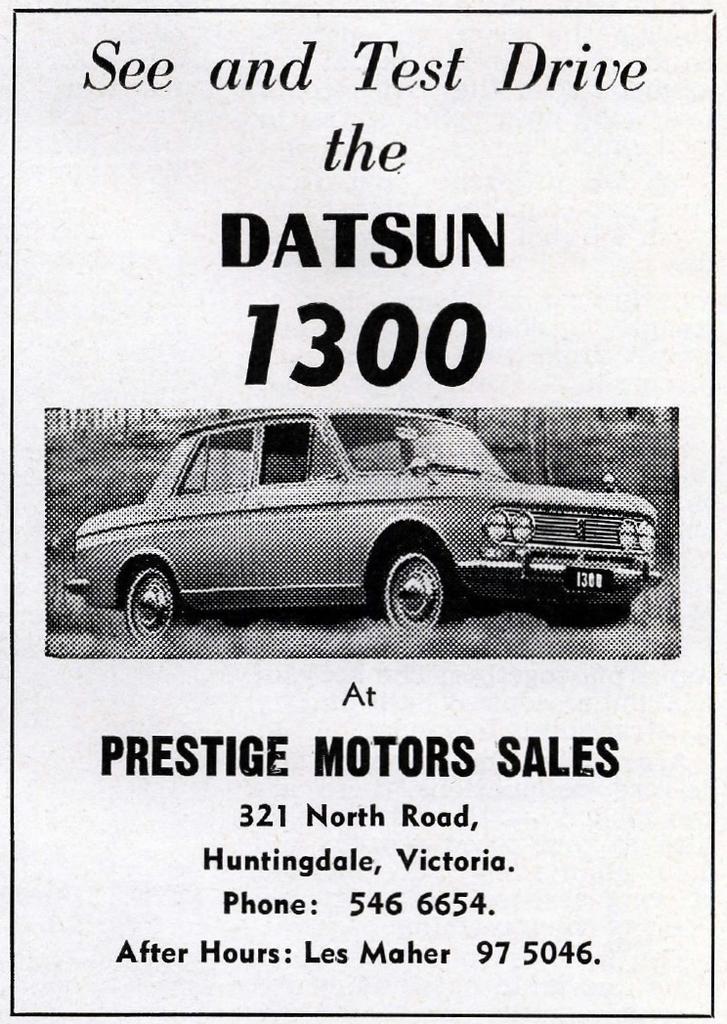Describe this image in one or two sentences. In this picture I can see a poster with some text and picture of a car. 